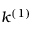<formula> <loc_0><loc_0><loc_500><loc_500>k ^ { ( 1 ) }</formula> 